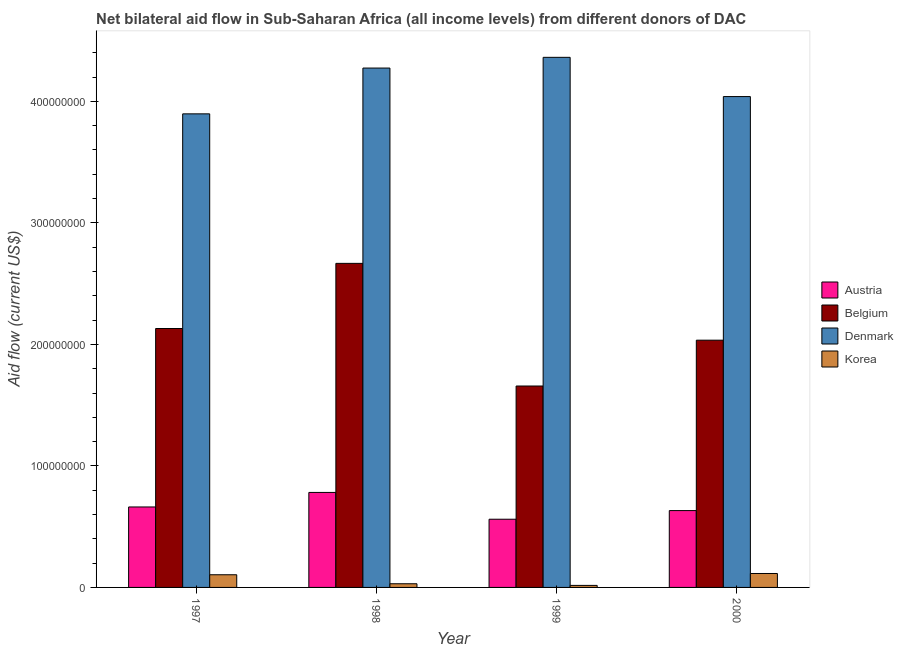How many different coloured bars are there?
Keep it short and to the point. 4. Are the number of bars per tick equal to the number of legend labels?
Give a very brief answer. Yes. How many bars are there on the 4th tick from the left?
Provide a succinct answer. 4. In how many cases, is the number of bars for a given year not equal to the number of legend labels?
Your answer should be very brief. 0. What is the amount of aid given by korea in 2000?
Provide a succinct answer. 1.15e+07. Across all years, what is the maximum amount of aid given by austria?
Make the answer very short. 7.82e+07. Across all years, what is the minimum amount of aid given by denmark?
Provide a succinct answer. 3.90e+08. What is the total amount of aid given by belgium in the graph?
Ensure brevity in your answer.  8.49e+08. What is the difference between the amount of aid given by austria in 1997 and that in 1999?
Offer a terse response. 1.01e+07. What is the difference between the amount of aid given by belgium in 1997 and the amount of aid given by denmark in 2000?
Your response must be concise. 9.61e+06. What is the average amount of aid given by belgium per year?
Your response must be concise. 2.12e+08. In the year 1998, what is the difference between the amount of aid given by belgium and amount of aid given by austria?
Offer a terse response. 0. In how many years, is the amount of aid given by austria greater than 140000000 US$?
Your answer should be very brief. 0. What is the ratio of the amount of aid given by belgium in 1997 to that in 1999?
Your answer should be very brief. 1.29. Is the difference between the amount of aid given by korea in 1999 and 2000 greater than the difference between the amount of aid given by denmark in 1999 and 2000?
Offer a terse response. No. What is the difference between the highest and the second highest amount of aid given by denmark?
Ensure brevity in your answer.  8.83e+06. What is the difference between the highest and the lowest amount of aid given by denmark?
Your answer should be compact. 4.65e+07. In how many years, is the amount of aid given by austria greater than the average amount of aid given by austria taken over all years?
Provide a succinct answer. 2. Is the sum of the amount of aid given by belgium in 1997 and 1998 greater than the maximum amount of aid given by denmark across all years?
Offer a terse response. Yes. What does the 2nd bar from the right in 1999 represents?
Offer a terse response. Denmark. Are all the bars in the graph horizontal?
Provide a short and direct response. No. How many years are there in the graph?
Provide a succinct answer. 4. Does the graph contain any zero values?
Ensure brevity in your answer.  No. How many legend labels are there?
Keep it short and to the point. 4. What is the title of the graph?
Your answer should be compact. Net bilateral aid flow in Sub-Saharan Africa (all income levels) from different donors of DAC. What is the label or title of the X-axis?
Offer a terse response. Year. What is the label or title of the Y-axis?
Provide a short and direct response. Aid flow (current US$). What is the Aid flow (current US$) in Austria in 1997?
Give a very brief answer. 6.62e+07. What is the Aid flow (current US$) of Belgium in 1997?
Provide a succinct answer. 2.13e+08. What is the Aid flow (current US$) in Denmark in 1997?
Your answer should be compact. 3.90e+08. What is the Aid flow (current US$) in Korea in 1997?
Keep it short and to the point. 1.04e+07. What is the Aid flow (current US$) of Austria in 1998?
Give a very brief answer. 7.82e+07. What is the Aid flow (current US$) of Belgium in 1998?
Give a very brief answer. 2.67e+08. What is the Aid flow (current US$) in Denmark in 1998?
Your answer should be very brief. 4.27e+08. What is the Aid flow (current US$) of Korea in 1998?
Provide a short and direct response. 3.02e+06. What is the Aid flow (current US$) in Austria in 1999?
Give a very brief answer. 5.61e+07. What is the Aid flow (current US$) in Belgium in 1999?
Your answer should be very brief. 1.66e+08. What is the Aid flow (current US$) in Denmark in 1999?
Provide a succinct answer. 4.36e+08. What is the Aid flow (current US$) in Korea in 1999?
Provide a succinct answer. 1.67e+06. What is the Aid flow (current US$) of Austria in 2000?
Your answer should be very brief. 6.32e+07. What is the Aid flow (current US$) of Belgium in 2000?
Your answer should be compact. 2.03e+08. What is the Aid flow (current US$) in Denmark in 2000?
Give a very brief answer. 4.04e+08. What is the Aid flow (current US$) in Korea in 2000?
Make the answer very short. 1.15e+07. Across all years, what is the maximum Aid flow (current US$) in Austria?
Your response must be concise. 7.82e+07. Across all years, what is the maximum Aid flow (current US$) of Belgium?
Provide a succinct answer. 2.67e+08. Across all years, what is the maximum Aid flow (current US$) of Denmark?
Your answer should be very brief. 4.36e+08. Across all years, what is the maximum Aid flow (current US$) of Korea?
Ensure brevity in your answer.  1.15e+07. Across all years, what is the minimum Aid flow (current US$) in Austria?
Your answer should be very brief. 5.61e+07. Across all years, what is the minimum Aid flow (current US$) in Belgium?
Offer a very short reply. 1.66e+08. Across all years, what is the minimum Aid flow (current US$) of Denmark?
Make the answer very short. 3.90e+08. Across all years, what is the minimum Aid flow (current US$) in Korea?
Offer a very short reply. 1.67e+06. What is the total Aid flow (current US$) of Austria in the graph?
Offer a terse response. 2.64e+08. What is the total Aid flow (current US$) of Belgium in the graph?
Your answer should be compact. 8.49e+08. What is the total Aid flow (current US$) of Denmark in the graph?
Ensure brevity in your answer.  1.66e+09. What is the total Aid flow (current US$) of Korea in the graph?
Provide a succinct answer. 2.66e+07. What is the difference between the Aid flow (current US$) of Austria in 1997 and that in 1998?
Keep it short and to the point. -1.20e+07. What is the difference between the Aid flow (current US$) in Belgium in 1997 and that in 1998?
Provide a succinct answer. -5.36e+07. What is the difference between the Aid flow (current US$) of Denmark in 1997 and that in 1998?
Your answer should be compact. -3.77e+07. What is the difference between the Aid flow (current US$) in Korea in 1997 and that in 1998?
Your response must be concise. 7.41e+06. What is the difference between the Aid flow (current US$) of Austria in 1997 and that in 1999?
Offer a very short reply. 1.01e+07. What is the difference between the Aid flow (current US$) of Belgium in 1997 and that in 1999?
Ensure brevity in your answer.  4.73e+07. What is the difference between the Aid flow (current US$) of Denmark in 1997 and that in 1999?
Ensure brevity in your answer.  -4.65e+07. What is the difference between the Aid flow (current US$) in Korea in 1997 and that in 1999?
Your answer should be very brief. 8.76e+06. What is the difference between the Aid flow (current US$) in Austria in 1997 and that in 2000?
Provide a short and direct response. 2.98e+06. What is the difference between the Aid flow (current US$) of Belgium in 1997 and that in 2000?
Keep it short and to the point. 9.61e+06. What is the difference between the Aid flow (current US$) in Denmark in 1997 and that in 2000?
Provide a succinct answer. -1.42e+07. What is the difference between the Aid flow (current US$) of Korea in 1997 and that in 2000?
Provide a succinct answer. -1.04e+06. What is the difference between the Aid flow (current US$) of Austria in 1998 and that in 1999?
Offer a terse response. 2.20e+07. What is the difference between the Aid flow (current US$) of Belgium in 1998 and that in 1999?
Your answer should be very brief. 1.01e+08. What is the difference between the Aid flow (current US$) in Denmark in 1998 and that in 1999?
Provide a short and direct response. -8.83e+06. What is the difference between the Aid flow (current US$) in Korea in 1998 and that in 1999?
Make the answer very short. 1.35e+06. What is the difference between the Aid flow (current US$) in Austria in 1998 and that in 2000?
Make the answer very short. 1.49e+07. What is the difference between the Aid flow (current US$) in Belgium in 1998 and that in 2000?
Give a very brief answer. 6.32e+07. What is the difference between the Aid flow (current US$) in Denmark in 1998 and that in 2000?
Make the answer very short. 2.35e+07. What is the difference between the Aid flow (current US$) in Korea in 1998 and that in 2000?
Provide a short and direct response. -8.45e+06. What is the difference between the Aid flow (current US$) in Austria in 1999 and that in 2000?
Give a very brief answer. -7.11e+06. What is the difference between the Aid flow (current US$) of Belgium in 1999 and that in 2000?
Offer a very short reply. -3.77e+07. What is the difference between the Aid flow (current US$) of Denmark in 1999 and that in 2000?
Keep it short and to the point. 3.23e+07. What is the difference between the Aid flow (current US$) in Korea in 1999 and that in 2000?
Your answer should be compact. -9.80e+06. What is the difference between the Aid flow (current US$) in Austria in 1997 and the Aid flow (current US$) in Belgium in 1998?
Your response must be concise. -2.00e+08. What is the difference between the Aid flow (current US$) of Austria in 1997 and the Aid flow (current US$) of Denmark in 1998?
Offer a very short reply. -3.61e+08. What is the difference between the Aid flow (current US$) of Austria in 1997 and the Aid flow (current US$) of Korea in 1998?
Your answer should be compact. 6.32e+07. What is the difference between the Aid flow (current US$) of Belgium in 1997 and the Aid flow (current US$) of Denmark in 1998?
Your response must be concise. -2.14e+08. What is the difference between the Aid flow (current US$) in Belgium in 1997 and the Aid flow (current US$) in Korea in 1998?
Offer a terse response. 2.10e+08. What is the difference between the Aid flow (current US$) in Denmark in 1997 and the Aid flow (current US$) in Korea in 1998?
Your response must be concise. 3.87e+08. What is the difference between the Aid flow (current US$) of Austria in 1997 and the Aid flow (current US$) of Belgium in 1999?
Provide a succinct answer. -9.95e+07. What is the difference between the Aid flow (current US$) of Austria in 1997 and the Aid flow (current US$) of Denmark in 1999?
Provide a succinct answer. -3.70e+08. What is the difference between the Aid flow (current US$) in Austria in 1997 and the Aid flow (current US$) in Korea in 1999?
Your answer should be compact. 6.46e+07. What is the difference between the Aid flow (current US$) of Belgium in 1997 and the Aid flow (current US$) of Denmark in 1999?
Offer a very short reply. -2.23e+08. What is the difference between the Aid flow (current US$) in Belgium in 1997 and the Aid flow (current US$) in Korea in 1999?
Provide a succinct answer. 2.11e+08. What is the difference between the Aid flow (current US$) in Denmark in 1997 and the Aid flow (current US$) in Korea in 1999?
Ensure brevity in your answer.  3.88e+08. What is the difference between the Aid flow (current US$) of Austria in 1997 and the Aid flow (current US$) of Belgium in 2000?
Provide a succinct answer. -1.37e+08. What is the difference between the Aid flow (current US$) in Austria in 1997 and the Aid flow (current US$) in Denmark in 2000?
Make the answer very short. -3.38e+08. What is the difference between the Aid flow (current US$) in Austria in 1997 and the Aid flow (current US$) in Korea in 2000?
Offer a very short reply. 5.48e+07. What is the difference between the Aid flow (current US$) in Belgium in 1997 and the Aid flow (current US$) in Denmark in 2000?
Offer a very short reply. -1.91e+08. What is the difference between the Aid flow (current US$) in Belgium in 1997 and the Aid flow (current US$) in Korea in 2000?
Provide a succinct answer. 2.02e+08. What is the difference between the Aid flow (current US$) of Denmark in 1997 and the Aid flow (current US$) of Korea in 2000?
Offer a very short reply. 3.78e+08. What is the difference between the Aid flow (current US$) in Austria in 1998 and the Aid flow (current US$) in Belgium in 1999?
Your answer should be compact. -8.76e+07. What is the difference between the Aid flow (current US$) of Austria in 1998 and the Aid flow (current US$) of Denmark in 1999?
Ensure brevity in your answer.  -3.58e+08. What is the difference between the Aid flow (current US$) of Austria in 1998 and the Aid flow (current US$) of Korea in 1999?
Offer a very short reply. 7.65e+07. What is the difference between the Aid flow (current US$) in Belgium in 1998 and the Aid flow (current US$) in Denmark in 1999?
Offer a terse response. -1.70e+08. What is the difference between the Aid flow (current US$) of Belgium in 1998 and the Aid flow (current US$) of Korea in 1999?
Your response must be concise. 2.65e+08. What is the difference between the Aid flow (current US$) in Denmark in 1998 and the Aid flow (current US$) in Korea in 1999?
Keep it short and to the point. 4.26e+08. What is the difference between the Aid flow (current US$) of Austria in 1998 and the Aid flow (current US$) of Belgium in 2000?
Keep it short and to the point. -1.25e+08. What is the difference between the Aid flow (current US$) in Austria in 1998 and the Aid flow (current US$) in Denmark in 2000?
Keep it short and to the point. -3.26e+08. What is the difference between the Aid flow (current US$) in Austria in 1998 and the Aid flow (current US$) in Korea in 2000?
Provide a succinct answer. 6.67e+07. What is the difference between the Aid flow (current US$) in Belgium in 1998 and the Aid flow (current US$) in Denmark in 2000?
Your answer should be compact. -1.37e+08. What is the difference between the Aid flow (current US$) of Belgium in 1998 and the Aid flow (current US$) of Korea in 2000?
Provide a succinct answer. 2.55e+08. What is the difference between the Aid flow (current US$) in Denmark in 1998 and the Aid flow (current US$) in Korea in 2000?
Provide a short and direct response. 4.16e+08. What is the difference between the Aid flow (current US$) of Austria in 1999 and the Aid flow (current US$) of Belgium in 2000?
Your response must be concise. -1.47e+08. What is the difference between the Aid flow (current US$) of Austria in 1999 and the Aid flow (current US$) of Denmark in 2000?
Provide a succinct answer. -3.48e+08. What is the difference between the Aid flow (current US$) in Austria in 1999 and the Aid flow (current US$) in Korea in 2000?
Your response must be concise. 4.47e+07. What is the difference between the Aid flow (current US$) in Belgium in 1999 and the Aid flow (current US$) in Denmark in 2000?
Offer a very short reply. -2.38e+08. What is the difference between the Aid flow (current US$) in Belgium in 1999 and the Aid flow (current US$) in Korea in 2000?
Make the answer very short. 1.54e+08. What is the difference between the Aid flow (current US$) of Denmark in 1999 and the Aid flow (current US$) of Korea in 2000?
Give a very brief answer. 4.25e+08. What is the average Aid flow (current US$) in Austria per year?
Your answer should be compact. 6.59e+07. What is the average Aid flow (current US$) of Belgium per year?
Your answer should be compact. 2.12e+08. What is the average Aid flow (current US$) in Denmark per year?
Keep it short and to the point. 4.14e+08. What is the average Aid flow (current US$) of Korea per year?
Provide a succinct answer. 6.65e+06. In the year 1997, what is the difference between the Aid flow (current US$) of Austria and Aid flow (current US$) of Belgium?
Your response must be concise. -1.47e+08. In the year 1997, what is the difference between the Aid flow (current US$) of Austria and Aid flow (current US$) of Denmark?
Your response must be concise. -3.24e+08. In the year 1997, what is the difference between the Aid flow (current US$) of Austria and Aid flow (current US$) of Korea?
Provide a succinct answer. 5.58e+07. In the year 1997, what is the difference between the Aid flow (current US$) in Belgium and Aid flow (current US$) in Denmark?
Provide a succinct answer. -1.77e+08. In the year 1997, what is the difference between the Aid flow (current US$) in Belgium and Aid flow (current US$) in Korea?
Ensure brevity in your answer.  2.03e+08. In the year 1997, what is the difference between the Aid flow (current US$) in Denmark and Aid flow (current US$) in Korea?
Make the answer very short. 3.79e+08. In the year 1998, what is the difference between the Aid flow (current US$) in Austria and Aid flow (current US$) in Belgium?
Provide a short and direct response. -1.88e+08. In the year 1998, what is the difference between the Aid flow (current US$) of Austria and Aid flow (current US$) of Denmark?
Your answer should be very brief. -3.49e+08. In the year 1998, what is the difference between the Aid flow (current US$) in Austria and Aid flow (current US$) in Korea?
Give a very brief answer. 7.52e+07. In the year 1998, what is the difference between the Aid flow (current US$) in Belgium and Aid flow (current US$) in Denmark?
Your answer should be compact. -1.61e+08. In the year 1998, what is the difference between the Aid flow (current US$) of Belgium and Aid flow (current US$) of Korea?
Your answer should be compact. 2.64e+08. In the year 1998, what is the difference between the Aid flow (current US$) of Denmark and Aid flow (current US$) of Korea?
Offer a terse response. 4.24e+08. In the year 1999, what is the difference between the Aid flow (current US$) of Austria and Aid flow (current US$) of Belgium?
Offer a terse response. -1.10e+08. In the year 1999, what is the difference between the Aid flow (current US$) in Austria and Aid flow (current US$) in Denmark?
Your answer should be very brief. -3.80e+08. In the year 1999, what is the difference between the Aid flow (current US$) of Austria and Aid flow (current US$) of Korea?
Ensure brevity in your answer.  5.45e+07. In the year 1999, what is the difference between the Aid flow (current US$) of Belgium and Aid flow (current US$) of Denmark?
Ensure brevity in your answer.  -2.70e+08. In the year 1999, what is the difference between the Aid flow (current US$) of Belgium and Aid flow (current US$) of Korea?
Your answer should be very brief. 1.64e+08. In the year 1999, what is the difference between the Aid flow (current US$) in Denmark and Aid flow (current US$) in Korea?
Your response must be concise. 4.35e+08. In the year 2000, what is the difference between the Aid flow (current US$) in Austria and Aid flow (current US$) in Belgium?
Keep it short and to the point. -1.40e+08. In the year 2000, what is the difference between the Aid flow (current US$) of Austria and Aid flow (current US$) of Denmark?
Give a very brief answer. -3.41e+08. In the year 2000, what is the difference between the Aid flow (current US$) of Austria and Aid flow (current US$) of Korea?
Ensure brevity in your answer.  5.18e+07. In the year 2000, what is the difference between the Aid flow (current US$) in Belgium and Aid flow (current US$) in Denmark?
Offer a very short reply. -2.00e+08. In the year 2000, what is the difference between the Aid flow (current US$) of Belgium and Aid flow (current US$) of Korea?
Ensure brevity in your answer.  1.92e+08. In the year 2000, what is the difference between the Aid flow (current US$) in Denmark and Aid flow (current US$) in Korea?
Provide a succinct answer. 3.92e+08. What is the ratio of the Aid flow (current US$) in Austria in 1997 to that in 1998?
Provide a succinct answer. 0.85. What is the ratio of the Aid flow (current US$) of Belgium in 1997 to that in 1998?
Provide a short and direct response. 0.8. What is the ratio of the Aid flow (current US$) in Denmark in 1997 to that in 1998?
Your response must be concise. 0.91. What is the ratio of the Aid flow (current US$) of Korea in 1997 to that in 1998?
Provide a short and direct response. 3.45. What is the ratio of the Aid flow (current US$) in Austria in 1997 to that in 1999?
Offer a terse response. 1.18. What is the ratio of the Aid flow (current US$) of Belgium in 1997 to that in 1999?
Ensure brevity in your answer.  1.29. What is the ratio of the Aid flow (current US$) of Denmark in 1997 to that in 1999?
Offer a terse response. 0.89. What is the ratio of the Aid flow (current US$) of Korea in 1997 to that in 1999?
Keep it short and to the point. 6.25. What is the ratio of the Aid flow (current US$) of Austria in 1997 to that in 2000?
Provide a short and direct response. 1.05. What is the ratio of the Aid flow (current US$) in Belgium in 1997 to that in 2000?
Give a very brief answer. 1.05. What is the ratio of the Aid flow (current US$) of Denmark in 1997 to that in 2000?
Give a very brief answer. 0.96. What is the ratio of the Aid flow (current US$) in Korea in 1997 to that in 2000?
Offer a very short reply. 0.91. What is the ratio of the Aid flow (current US$) of Austria in 1998 to that in 1999?
Your answer should be very brief. 1.39. What is the ratio of the Aid flow (current US$) of Belgium in 1998 to that in 1999?
Your answer should be compact. 1.61. What is the ratio of the Aid flow (current US$) in Denmark in 1998 to that in 1999?
Keep it short and to the point. 0.98. What is the ratio of the Aid flow (current US$) of Korea in 1998 to that in 1999?
Offer a terse response. 1.81. What is the ratio of the Aid flow (current US$) of Austria in 1998 to that in 2000?
Provide a short and direct response. 1.24. What is the ratio of the Aid flow (current US$) of Belgium in 1998 to that in 2000?
Provide a short and direct response. 1.31. What is the ratio of the Aid flow (current US$) in Denmark in 1998 to that in 2000?
Offer a very short reply. 1.06. What is the ratio of the Aid flow (current US$) in Korea in 1998 to that in 2000?
Give a very brief answer. 0.26. What is the ratio of the Aid flow (current US$) of Austria in 1999 to that in 2000?
Your answer should be very brief. 0.89. What is the ratio of the Aid flow (current US$) of Belgium in 1999 to that in 2000?
Give a very brief answer. 0.81. What is the ratio of the Aid flow (current US$) of Denmark in 1999 to that in 2000?
Offer a terse response. 1.08. What is the ratio of the Aid flow (current US$) in Korea in 1999 to that in 2000?
Keep it short and to the point. 0.15. What is the difference between the highest and the second highest Aid flow (current US$) in Austria?
Give a very brief answer. 1.20e+07. What is the difference between the highest and the second highest Aid flow (current US$) in Belgium?
Offer a very short reply. 5.36e+07. What is the difference between the highest and the second highest Aid flow (current US$) in Denmark?
Your answer should be compact. 8.83e+06. What is the difference between the highest and the second highest Aid flow (current US$) in Korea?
Provide a succinct answer. 1.04e+06. What is the difference between the highest and the lowest Aid flow (current US$) of Austria?
Make the answer very short. 2.20e+07. What is the difference between the highest and the lowest Aid flow (current US$) of Belgium?
Your answer should be compact. 1.01e+08. What is the difference between the highest and the lowest Aid flow (current US$) in Denmark?
Provide a short and direct response. 4.65e+07. What is the difference between the highest and the lowest Aid flow (current US$) of Korea?
Keep it short and to the point. 9.80e+06. 